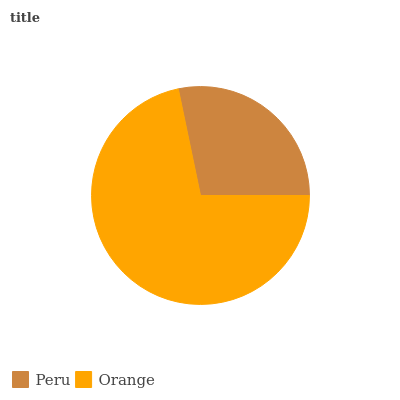Is Peru the minimum?
Answer yes or no. Yes. Is Orange the maximum?
Answer yes or no. Yes. Is Orange the minimum?
Answer yes or no. No. Is Orange greater than Peru?
Answer yes or no. Yes. Is Peru less than Orange?
Answer yes or no. Yes. Is Peru greater than Orange?
Answer yes or no. No. Is Orange less than Peru?
Answer yes or no. No. Is Orange the high median?
Answer yes or no. Yes. Is Peru the low median?
Answer yes or no. Yes. Is Peru the high median?
Answer yes or no. No. Is Orange the low median?
Answer yes or no. No. 